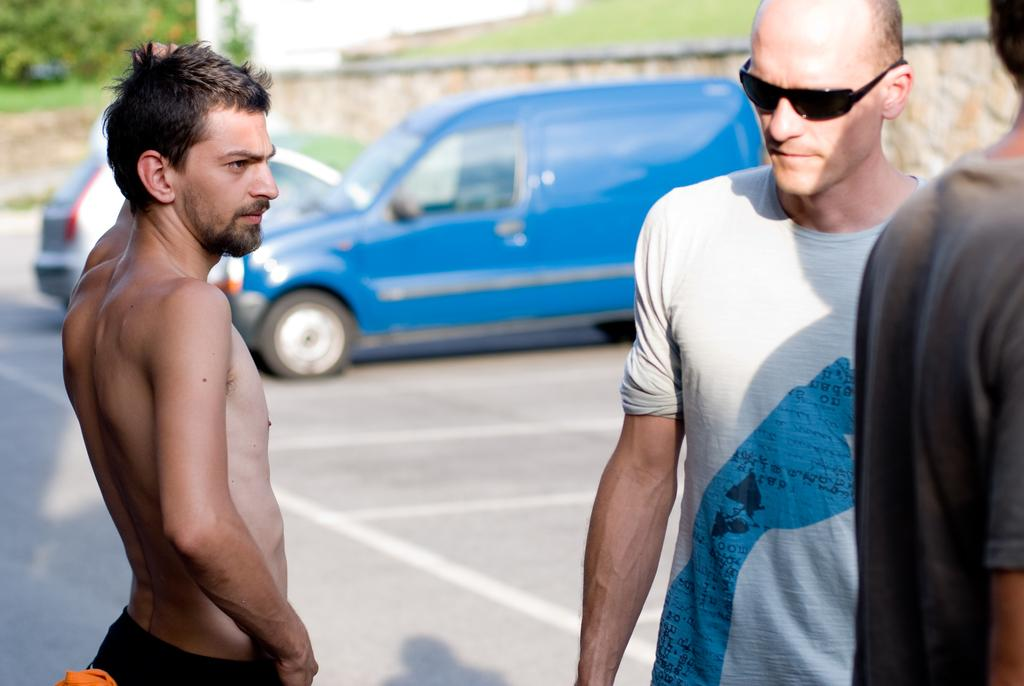What type of protective eyewear can be seen in the image? There are goggles in the image. How many people are standing in the image? There are three people standing in the image. What can be seen on the road in the image? Vehicles are present on the road in the image. What type of vegetation is visible in the background of the image? There are trees present in the background of the image. What type of structures can be seen in the background of the image? There are walls in the background of the image. What is the tendency of the carriage in the image? There is no carriage present in the image. How does the breath of the people affect the image? The image does not show any visible breath, and the people's breath does not affect the image. 